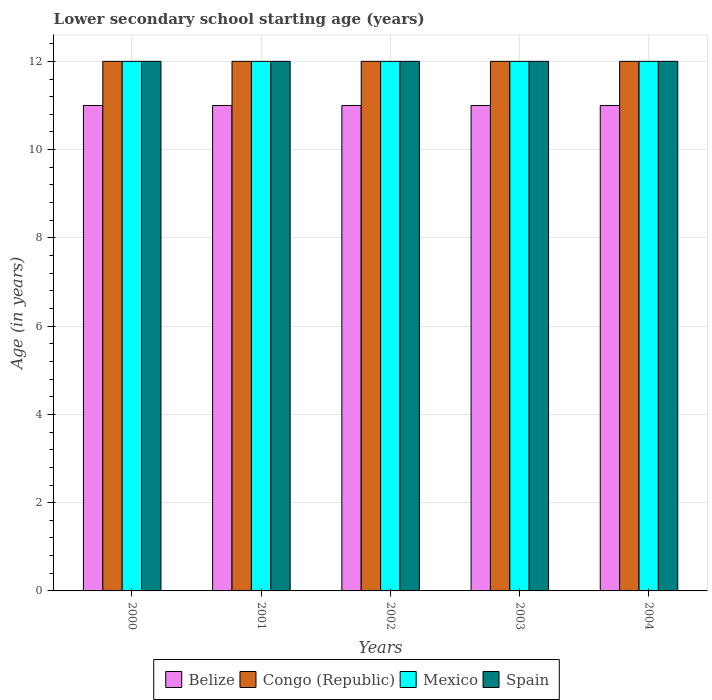How many different coloured bars are there?
Offer a very short reply. 4. How many groups of bars are there?
Provide a succinct answer. 5. What is the label of the 4th group of bars from the left?
Your answer should be compact. 2003. What is the lower secondary school starting age of children in Congo (Republic) in 2000?
Your answer should be compact. 12. Across all years, what is the maximum lower secondary school starting age of children in Belize?
Give a very brief answer. 11. Across all years, what is the minimum lower secondary school starting age of children in Spain?
Ensure brevity in your answer.  12. In which year was the lower secondary school starting age of children in Mexico maximum?
Keep it short and to the point. 2000. What is the total lower secondary school starting age of children in Congo (Republic) in the graph?
Ensure brevity in your answer.  60. What is the difference between the lower secondary school starting age of children in Spain in 2000 and that in 2004?
Give a very brief answer. 0. In the year 2001, what is the difference between the lower secondary school starting age of children in Mexico and lower secondary school starting age of children in Belize?
Provide a succinct answer. 1. In how many years, is the lower secondary school starting age of children in Spain greater than 12 years?
Your answer should be compact. 0. What is the difference between the highest and the second highest lower secondary school starting age of children in Mexico?
Make the answer very short. 0. In how many years, is the lower secondary school starting age of children in Spain greater than the average lower secondary school starting age of children in Spain taken over all years?
Keep it short and to the point. 0. What does the 1st bar from the left in 2004 represents?
Keep it short and to the point. Belize. What does the 2nd bar from the right in 2001 represents?
Your response must be concise. Mexico. How many bars are there?
Ensure brevity in your answer.  20. Are all the bars in the graph horizontal?
Keep it short and to the point. No. What is the difference between two consecutive major ticks on the Y-axis?
Make the answer very short. 2. How many legend labels are there?
Provide a short and direct response. 4. What is the title of the graph?
Your response must be concise. Lower secondary school starting age (years). Does "Andorra" appear as one of the legend labels in the graph?
Your answer should be very brief. No. What is the label or title of the X-axis?
Offer a terse response. Years. What is the label or title of the Y-axis?
Offer a terse response. Age (in years). What is the Age (in years) in Mexico in 2000?
Give a very brief answer. 12. What is the Age (in years) in Spain in 2000?
Keep it short and to the point. 12. What is the Age (in years) in Belize in 2001?
Keep it short and to the point. 11. What is the Age (in years) of Congo (Republic) in 2001?
Provide a succinct answer. 12. What is the Age (in years) in Mexico in 2002?
Ensure brevity in your answer.  12. What is the Age (in years) in Spain in 2002?
Give a very brief answer. 12. What is the Age (in years) in Congo (Republic) in 2003?
Your answer should be very brief. 12. What is the Age (in years) of Mexico in 2003?
Give a very brief answer. 12. What is the Age (in years) of Spain in 2003?
Your answer should be compact. 12. What is the Age (in years) of Spain in 2004?
Keep it short and to the point. 12. Across all years, what is the minimum Age (in years) of Belize?
Keep it short and to the point. 11. Across all years, what is the minimum Age (in years) of Mexico?
Offer a terse response. 12. Across all years, what is the minimum Age (in years) in Spain?
Ensure brevity in your answer.  12. What is the total Age (in years) in Mexico in the graph?
Offer a terse response. 60. What is the difference between the Age (in years) in Mexico in 2000 and that in 2001?
Make the answer very short. 0. What is the difference between the Age (in years) of Spain in 2000 and that in 2001?
Provide a short and direct response. 0. What is the difference between the Age (in years) in Belize in 2000 and that in 2002?
Provide a succinct answer. 0. What is the difference between the Age (in years) of Congo (Republic) in 2000 and that in 2003?
Give a very brief answer. 0. What is the difference between the Age (in years) in Mexico in 2000 and that in 2004?
Give a very brief answer. 0. What is the difference between the Age (in years) in Belize in 2001 and that in 2002?
Ensure brevity in your answer.  0. What is the difference between the Age (in years) in Congo (Republic) in 2001 and that in 2002?
Your answer should be compact. 0. What is the difference between the Age (in years) of Mexico in 2001 and that in 2002?
Make the answer very short. 0. What is the difference between the Age (in years) in Mexico in 2001 and that in 2003?
Your response must be concise. 0. What is the difference between the Age (in years) in Belize in 2002 and that in 2003?
Offer a very short reply. 0. What is the difference between the Age (in years) of Spain in 2002 and that in 2003?
Your answer should be very brief. 0. What is the difference between the Age (in years) in Congo (Republic) in 2002 and that in 2004?
Ensure brevity in your answer.  0. What is the difference between the Age (in years) of Mexico in 2002 and that in 2004?
Your answer should be very brief. 0. What is the difference between the Age (in years) of Spain in 2002 and that in 2004?
Provide a succinct answer. 0. What is the difference between the Age (in years) of Mexico in 2003 and that in 2004?
Your answer should be compact. 0. What is the difference between the Age (in years) in Belize in 2000 and the Age (in years) in Congo (Republic) in 2001?
Offer a very short reply. -1. What is the difference between the Age (in years) of Belize in 2000 and the Age (in years) of Spain in 2001?
Provide a short and direct response. -1. What is the difference between the Age (in years) of Congo (Republic) in 2000 and the Age (in years) of Spain in 2001?
Ensure brevity in your answer.  0. What is the difference between the Age (in years) of Belize in 2000 and the Age (in years) of Spain in 2002?
Ensure brevity in your answer.  -1. What is the difference between the Age (in years) in Congo (Republic) in 2000 and the Age (in years) in Spain in 2002?
Your response must be concise. 0. What is the difference between the Age (in years) in Belize in 2000 and the Age (in years) in Congo (Republic) in 2004?
Provide a short and direct response. -1. What is the difference between the Age (in years) in Belize in 2000 and the Age (in years) in Spain in 2004?
Provide a succinct answer. -1. What is the difference between the Age (in years) in Congo (Republic) in 2000 and the Age (in years) in Mexico in 2004?
Make the answer very short. 0. What is the difference between the Age (in years) in Belize in 2001 and the Age (in years) in Congo (Republic) in 2002?
Your answer should be very brief. -1. What is the difference between the Age (in years) of Belize in 2001 and the Age (in years) of Mexico in 2002?
Ensure brevity in your answer.  -1. What is the difference between the Age (in years) of Congo (Republic) in 2001 and the Age (in years) of Mexico in 2002?
Give a very brief answer. 0. What is the difference between the Age (in years) in Congo (Republic) in 2001 and the Age (in years) in Spain in 2002?
Give a very brief answer. 0. What is the difference between the Age (in years) in Belize in 2001 and the Age (in years) in Congo (Republic) in 2004?
Your answer should be compact. -1. What is the difference between the Age (in years) in Congo (Republic) in 2001 and the Age (in years) in Mexico in 2004?
Provide a short and direct response. 0. What is the difference between the Age (in years) in Mexico in 2001 and the Age (in years) in Spain in 2004?
Ensure brevity in your answer.  0. What is the difference between the Age (in years) in Belize in 2002 and the Age (in years) in Mexico in 2003?
Your answer should be very brief. -1. What is the difference between the Age (in years) in Belize in 2002 and the Age (in years) in Spain in 2003?
Keep it short and to the point. -1. What is the difference between the Age (in years) of Congo (Republic) in 2002 and the Age (in years) of Mexico in 2003?
Offer a very short reply. 0. What is the difference between the Age (in years) in Belize in 2002 and the Age (in years) in Congo (Republic) in 2004?
Give a very brief answer. -1. What is the difference between the Age (in years) of Belize in 2002 and the Age (in years) of Mexico in 2004?
Make the answer very short. -1. What is the difference between the Age (in years) in Congo (Republic) in 2002 and the Age (in years) in Spain in 2004?
Offer a very short reply. 0. What is the difference between the Age (in years) of Mexico in 2002 and the Age (in years) of Spain in 2004?
Give a very brief answer. 0. What is the difference between the Age (in years) of Belize in 2003 and the Age (in years) of Congo (Republic) in 2004?
Your answer should be compact. -1. What is the difference between the Age (in years) in Belize in 2003 and the Age (in years) in Mexico in 2004?
Offer a very short reply. -1. What is the average Age (in years) in Congo (Republic) per year?
Your answer should be very brief. 12. What is the average Age (in years) of Spain per year?
Offer a very short reply. 12. In the year 2000, what is the difference between the Age (in years) in Congo (Republic) and Age (in years) in Mexico?
Offer a very short reply. 0. In the year 2000, what is the difference between the Age (in years) in Mexico and Age (in years) in Spain?
Keep it short and to the point. 0. In the year 2001, what is the difference between the Age (in years) of Belize and Age (in years) of Congo (Republic)?
Keep it short and to the point. -1. In the year 2001, what is the difference between the Age (in years) in Congo (Republic) and Age (in years) in Mexico?
Give a very brief answer. 0. In the year 2001, what is the difference between the Age (in years) in Congo (Republic) and Age (in years) in Spain?
Offer a very short reply. 0. In the year 2002, what is the difference between the Age (in years) in Belize and Age (in years) in Spain?
Offer a terse response. -1. In the year 2002, what is the difference between the Age (in years) in Congo (Republic) and Age (in years) in Mexico?
Offer a very short reply. 0. In the year 2002, what is the difference between the Age (in years) of Mexico and Age (in years) of Spain?
Provide a short and direct response. 0. In the year 2003, what is the difference between the Age (in years) in Belize and Age (in years) in Congo (Republic)?
Offer a very short reply. -1. In the year 2003, what is the difference between the Age (in years) in Congo (Republic) and Age (in years) in Mexico?
Keep it short and to the point. 0. In the year 2004, what is the difference between the Age (in years) of Belize and Age (in years) of Congo (Republic)?
Provide a short and direct response. -1. In the year 2004, what is the difference between the Age (in years) in Congo (Republic) and Age (in years) in Mexico?
Offer a terse response. 0. In the year 2004, what is the difference between the Age (in years) in Mexico and Age (in years) in Spain?
Your answer should be compact. 0. What is the ratio of the Age (in years) in Belize in 2000 to that in 2001?
Offer a very short reply. 1. What is the ratio of the Age (in years) of Congo (Republic) in 2000 to that in 2001?
Provide a short and direct response. 1. What is the ratio of the Age (in years) in Spain in 2000 to that in 2001?
Your answer should be compact. 1. What is the ratio of the Age (in years) of Belize in 2000 to that in 2002?
Give a very brief answer. 1. What is the ratio of the Age (in years) in Congo (Republic) in 2000 to that in 2002?
Make the answer very short. 1. What is the ratio of the Age (in years) in Mexico in 2000 to that in 2002?
Your response must be concise. 1. What is the ratio of the Age (in years) in Spain in 2000 to that in 2002?
Make the answer very short. 1. What is the ratio of the Age (in years) of Belize in 2000 to that in 2003?
Your answer should be very brief. 1. What is the ratio of the Age (in years) of Congo (Republic) in 2000 to that in 2003?
Make the answer very short. 1. What is the ratio of the Age (in years) in Spain in 2000 to that in 2003?
Keep it short and to the point. 1. What is the ratio of the Age (in years) of Belize in 2001 to that in 2002?
Keep it short and to the point. 1. What is the ratio of the Age (in years) of Congo (Republic) in 2001 to that in 2002?
Offer a very short reply. 1. What is the ratio of the Age (in years) of Spain in 2001 to that in 2002?
Provide a succinct answer. 1. What is the ratio of the Age (in years) of Mexico in 2001 to that in 2003?
Keep it short and to the point. 1. What is the ratio of the Age (in years) in Spain in 2001 to that in 2003?
Offer a terse response. 1. What is the ratio of the Age (in years) in Belize in 2001 to that in 2004?
Give a very brief answer. 1. What is the ratio of the Age (in years) of Mexico in 2001 to that in 2004?
Provide a succinct answer. 1. What is the ratio of the Age (in years) in Belize in 2002 to that in 2003?
Your answer should be very brief. 1. What is the ratio of the Age (in years) of Congo (Republic) in 2002 to that in 2003?
Ensure brevity in your answer.  1. What is the ratio of the Age (in years) in Mexico in 2002 to that in 2003?
Offer a terse response. 1. What is the ratio of the Age (in years) of Belize in 2002 to that in 2004?
Provide a short and direct response. 1. What is the ratio of the Age (in years) in Belize in 2003 to that in 2004?
Your answer should be compact. 1. What is the ratio of the Age (in years) of Congo (Republic) in 2003 to that in 2004?
Provide a short and direct response. 1. What is the ratio of the Age (in years) of Mexico in 2003 to that in 2004?
Make the answer very short. 1. What is the difference between the highest and the second highest Age (in years) of Spain?
Your answer should be very brief. 0. What is the difference between the highest and the lowest Age (in years) of Congo (Republic)?
Ensure brevity in your answer.  0. What is the difference between the highest and the lowest Age (in years) of Mexico?
Offer a very short reply. 0. 